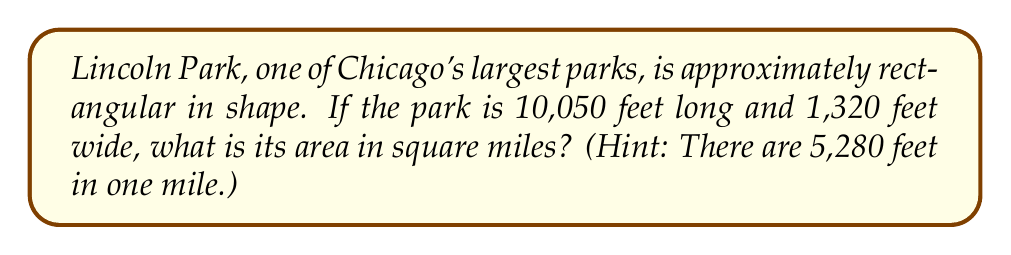What is the answer to this math problem? To solve this problem, we'll follow these steps:

1. Calculate the area of Lincoln Park in square feet:
   $$\text{Area} = \text{Length} \times \text{Width}$$
   $$\text{Area} = 10,050 \text{ ft} \times 1,320 \text{ ft} = 13,266,000 \text{ sq ft}$$

2. Convert square feet to square miles:
   We know that 1 mile = 5,280 feet, so 1 square mile = 5,280 ft × 5,280 ft = 27,878,400 sq ft

   To convert, we divide the area in square feet by the number of square feet in a square mile:
   $$\text{Area in sq miles} = \frac{13,266,000 \text{ sq ft}}{27,878,400 \text{ sq ft/sq mile}}$$

3. Perform the division:
   $$\text{Area in sq miles} = 0.4759 \text{ sq miles}$$

4. Round to two decimal places:
   $$\text{Area} \approx 0.48 \text{ sq miles}$$
Answer: 0.48 sq miles 